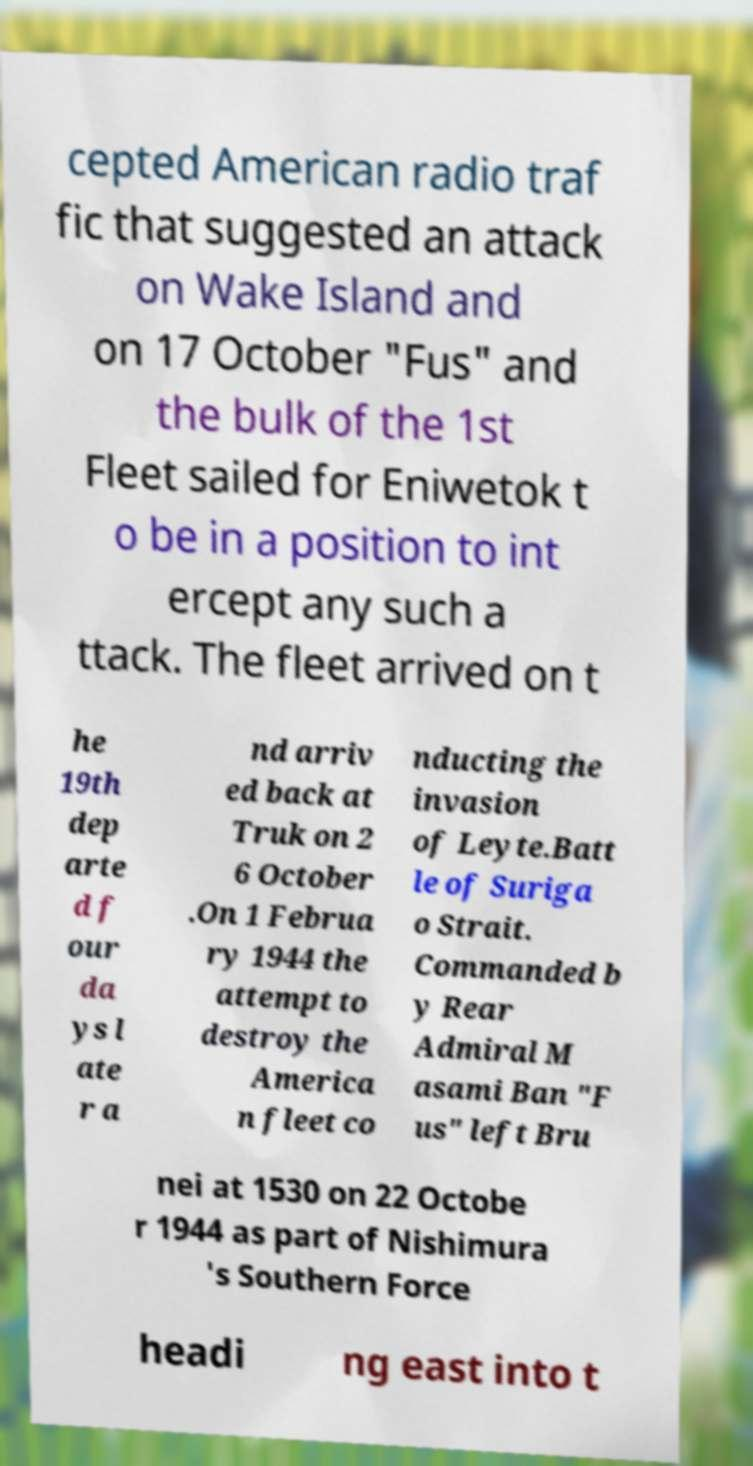I need the written content from this picture converted into text. Can you do that? cepted American radio traf fic that suggested an attack on Wake Island and on 17 October "Fus" and the bulk of the 1st Fleet sailed for Eniwetok t o be in a position to int ercept any such a ttack. The fleet arrived on t he 19th dep arte d f our da ys l ate r a nd arriv ed back at Truk on 2 6 October .On 1 Februa ry 1944 the attempt to destroy the America n fleet co nducting the invasion of Leyte.Batt le of Suriga o Strait. Commanded b y Rear Admiral M asami Ban "F us" left Bru nei at 1530 on 22 Octobe r 1944 as part of Nishimura 's Southern Force headi ng east into t 